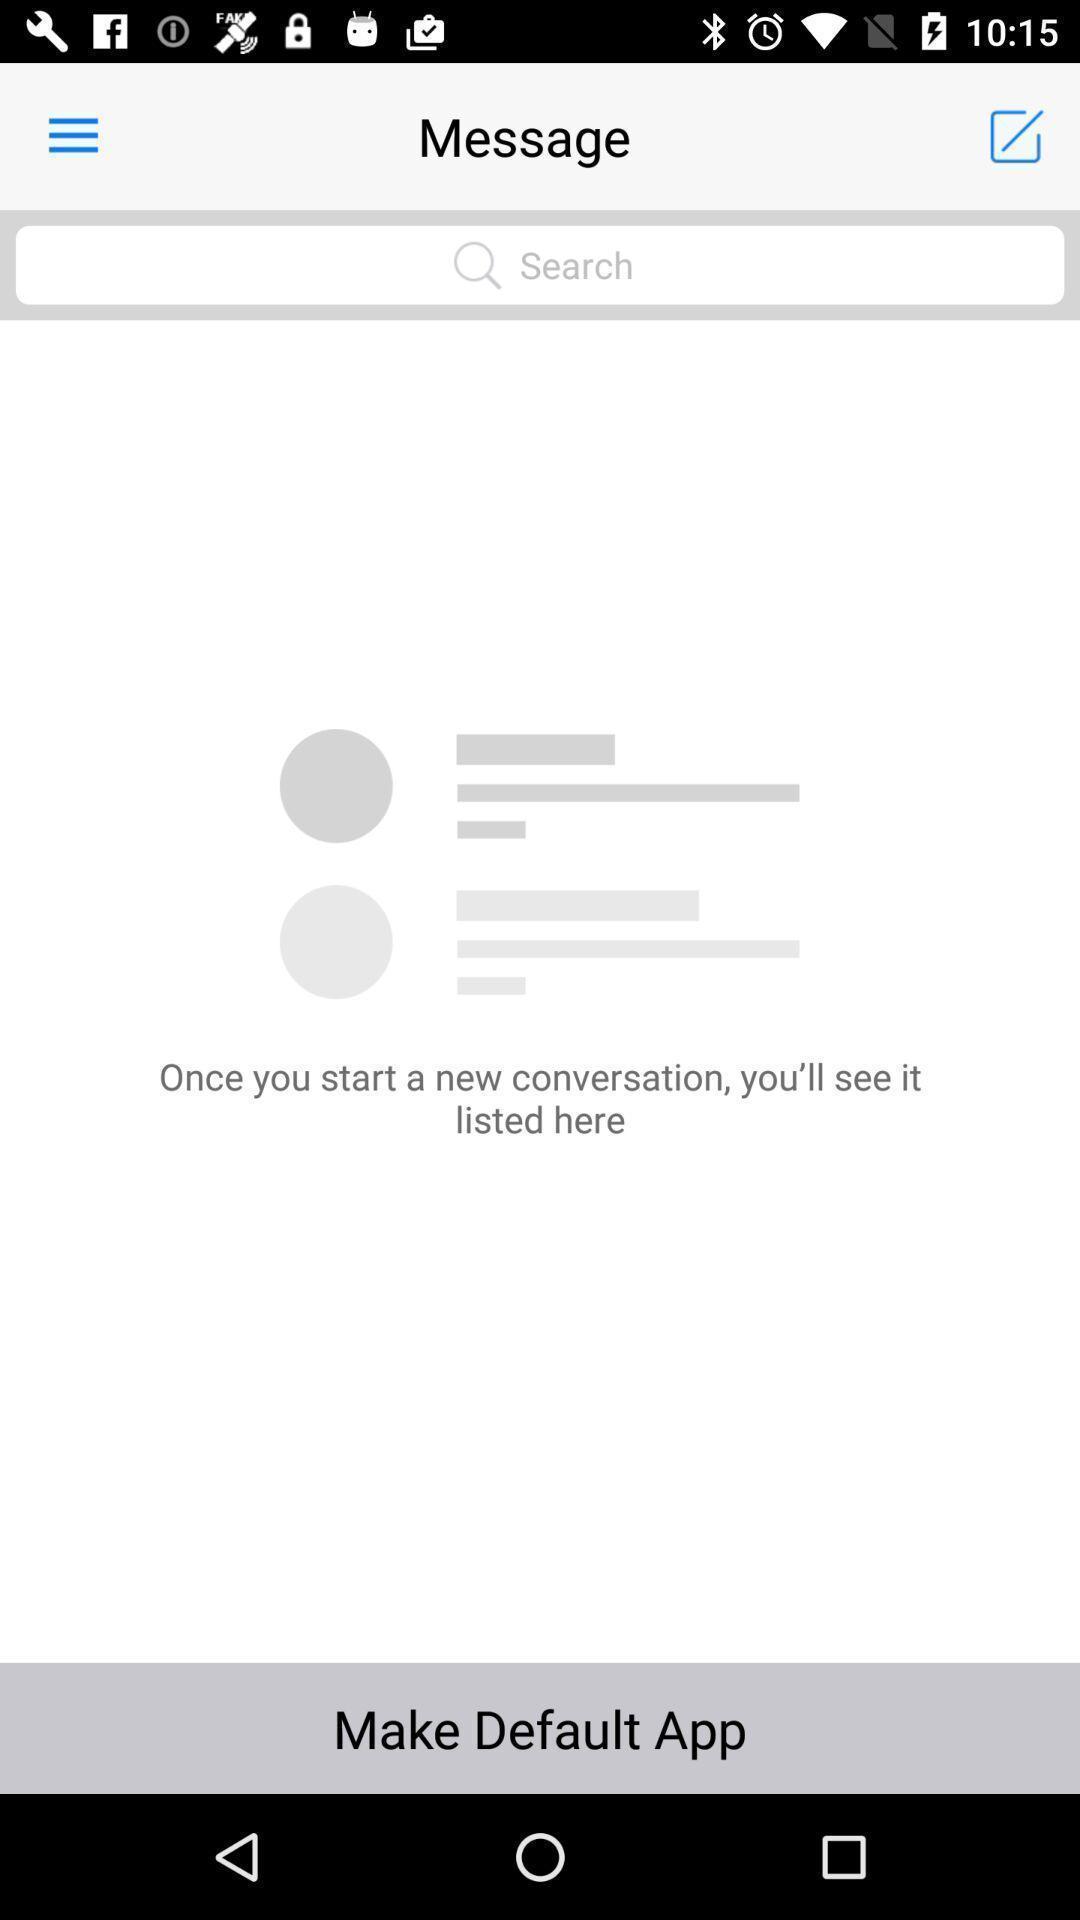Provide a textual representation of this image. Search bar in a messaging app. 